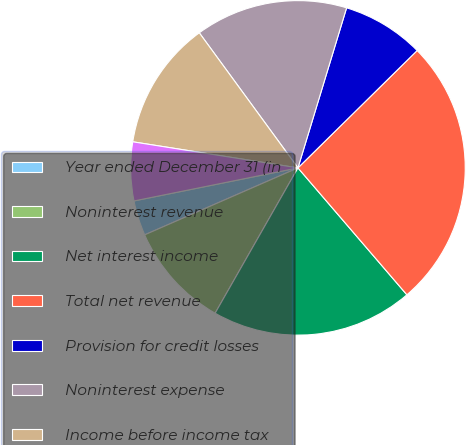Convert chart. <chart><loc_0><loc_0><loc_500><loc_500><pie_chart><fcel>Year ended December 31 (in<fcel>Noninterest revenue<fcel>Net interest income<fcel>Total net revenue<fcel>Provision for credit losses<fcel>Noninterest expense<fcel>Income before income tax<fcel>Net income<nl><fcel>3.39%<fcel>10.2%<fcel>19.54%<fcel>26.09%<fcel>7.93%<fcel>14.74%<fcel>12.47%<fcel>5.66%<nl></chart> 